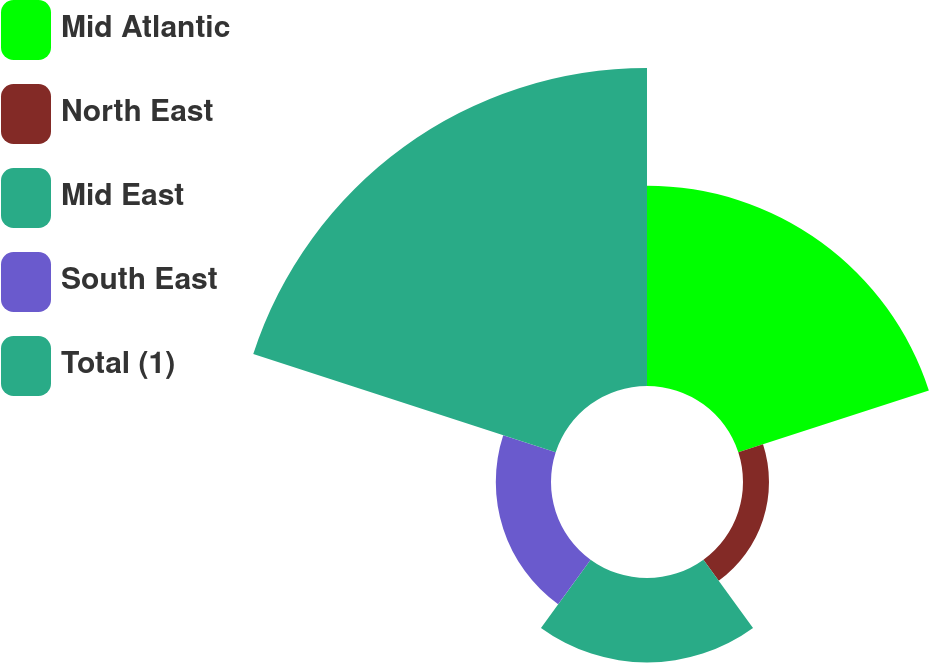Convert chart. <chart><loc_0><loc_0><loc_500><loc_500><pie_chart><fcel>Mid Atlantic<fcel>North East<fcel>Mid East<fcel>South East<fcel>Total (1)<nl><fcel>29.3%<fcel>3.8%<fcel>12.34%<fcel>8.07%<fcel>46.5%<nl></chart> 